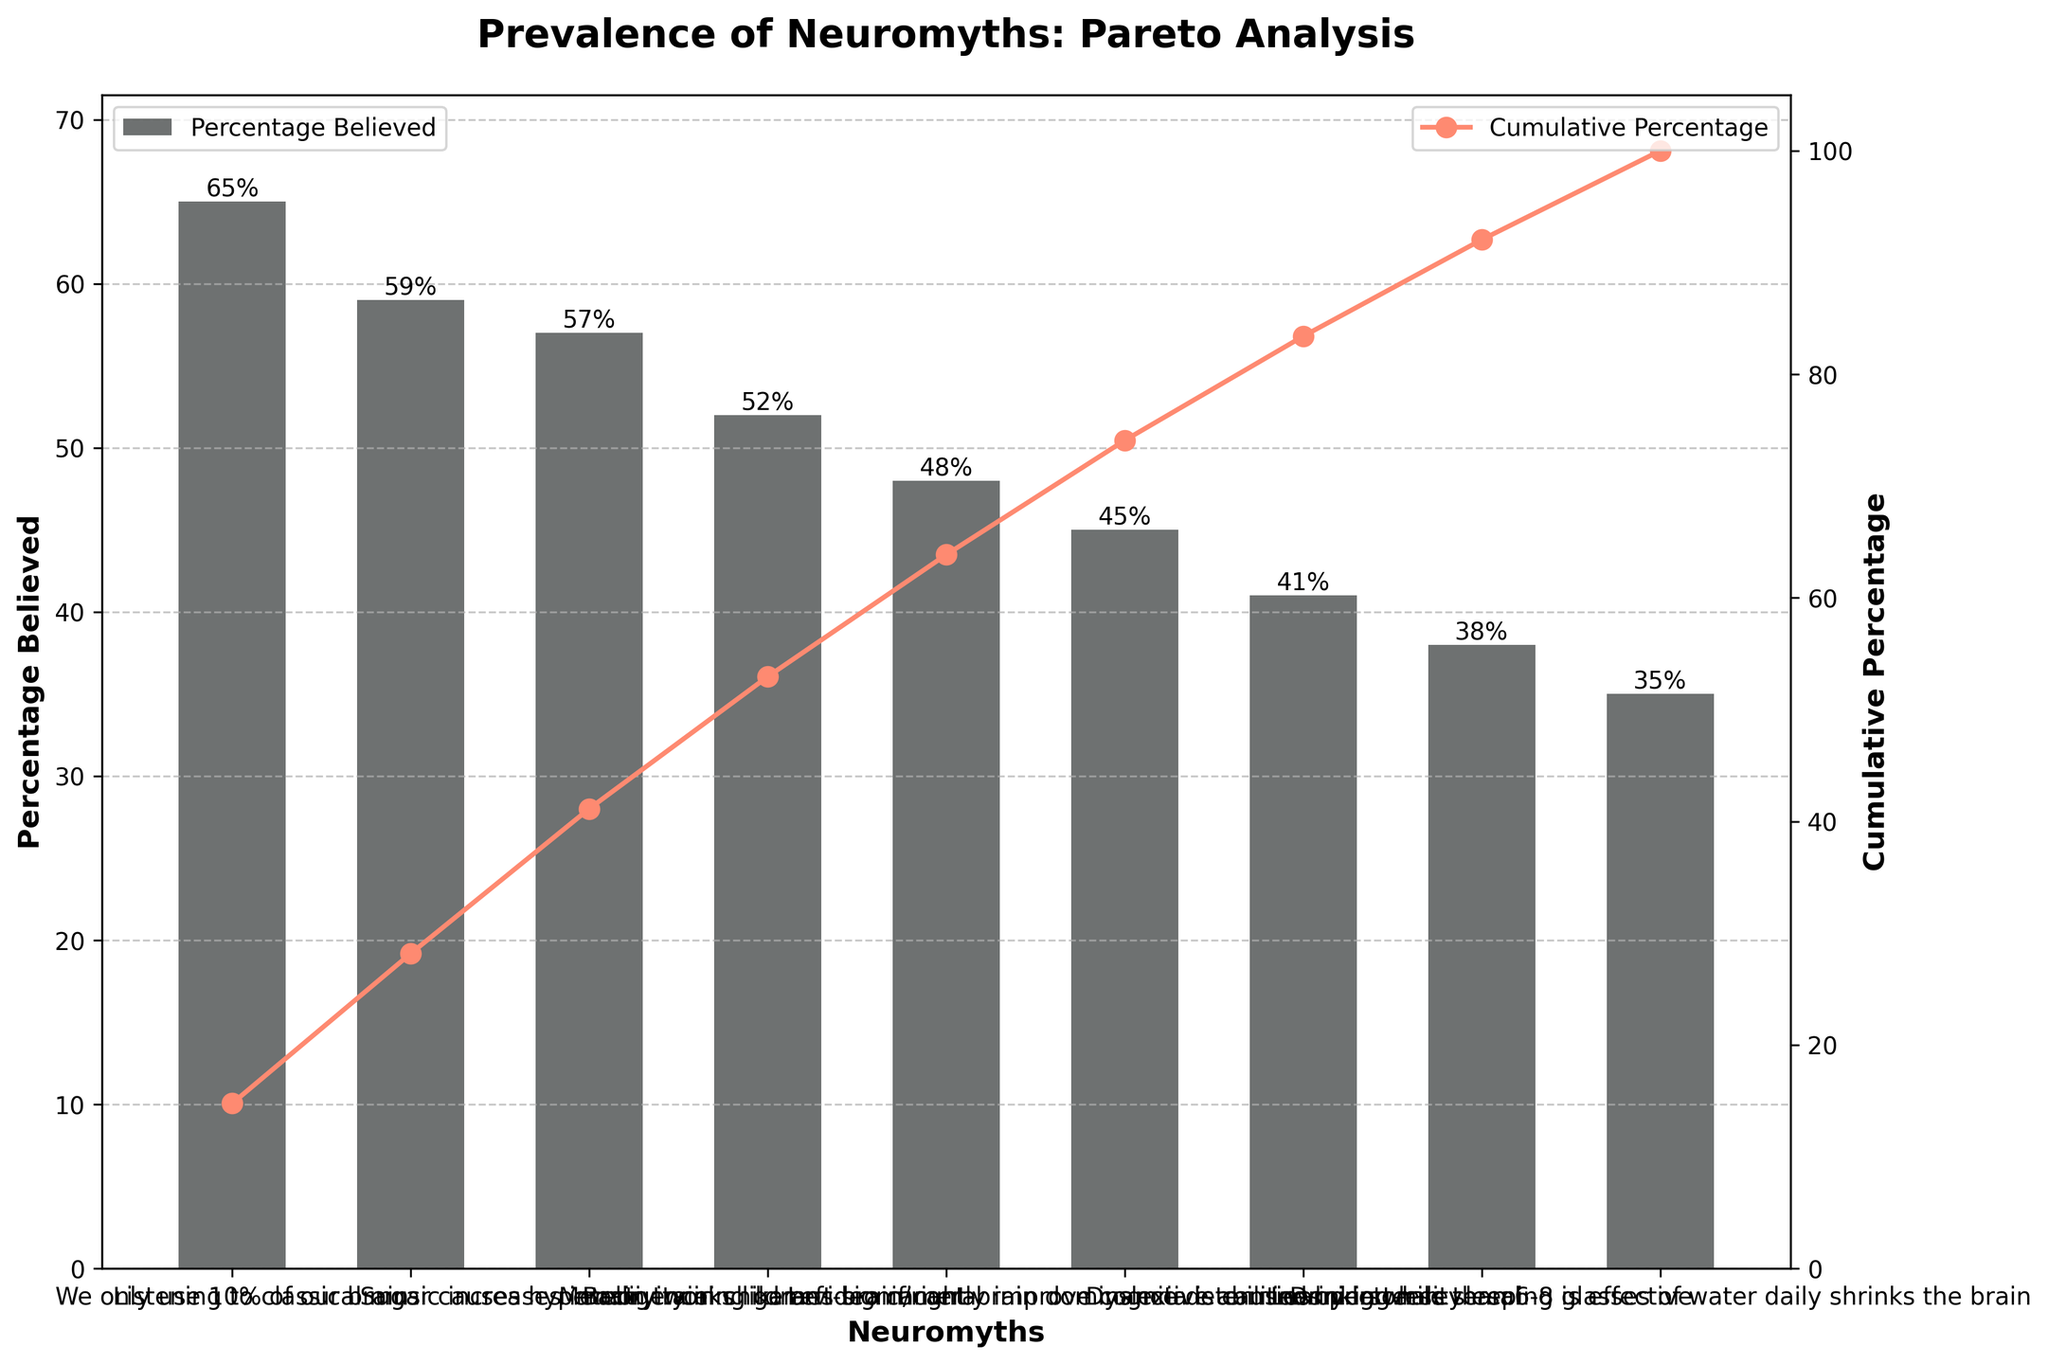What is the neuromyth with the highest percentage believed? Looking at the figure, the neuromyth at the top bar, "We only use 10% of our brain," has the highest percentage believed at 65%.
Answer: We only use 10% of our brain What is the cumulative percentage of belief after considering the top two neuromyths? According to the cumulative percentage line, summing the percentages for "We only use 10% of our brain" (65%) and "Listening to classical music increases intelligence" (59%) gives a cumulative percentage of approximately 73%.
Answer: Approximately 73% Which neuromyth has a belief percentage of 48%? The bar labeled "Brain training games significantly improve cognitive abilities" is at 48%.
Answer: Brain training games significantly improve cognitive abilities How many neuromyths have a belief percentage above 50%? The figure shows bars for the neuromyths "We only use 10% of our brain" (65%), "Listening to classical music increases intelligence" (59%), "Sugar causes hyperactivity in children" (57%), and "Memory works like a video camera" (52%). This sums to four neuromyths above 50%.
Answer: Four Between "Dyslexia is caused by letter reversal" and "Learning while sleeping is effective", which neuromyth is more widely believed? Referring to the respective bars, "Dyslexia is caused by letter reversal" has 41%, while "Learning while sleeping is effective" has 38%. Hence, "Dyslexia is caused by letter reversal" is more widely believed.
Answer: Dyslexia is caused by letter reversal What is the proportion of people who do not believe in any of the neuromyths listed? From the cumulative percentage line, if the highest cumulative belief percentage is slightly over 100%, the proportion of people not believing any neuromyths is 0%.
Answer: 0% What is the title of the figure? The title of the Pareto chart is "Prevalence of Neuromyths: Pareto Analysis".
Answer: Prevalence of Neuromyths: Pareto Analysis If we consider neuromyths having at least a 50% belief rate, what is their combined percentage? Summing the belief percentages for neuromyths with at least 50% belief: "We only use 10% of our brain" (65%), "Listening to classical music increases intelligence" (59%), "Sugar causes hyperactivity in children" (57%), and "Memory works like a video camera" (52%) gives a combined percentage of 233%.
Answer: 233% Which neuromyth marks the transition from the most to the least prevalent, defined by a cumulative percentage reaching 50%? By examining the cumulative percentage line, "Listening to classical music increases intelligence" is the second neuromyth listed but reaches near 62%. Hence it crosses the 50% mark.
Answer: Listening to classical music increases intelligence 